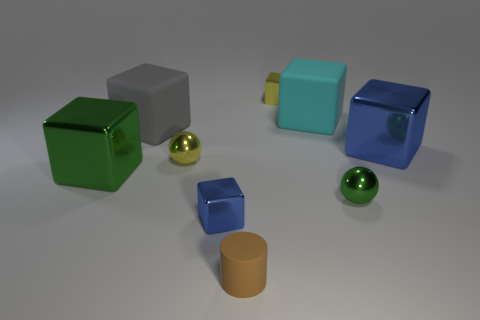Do the metal block that is behind the large gray matte cube and the block on the right side of the cyan rubber block have the same size?
Give a very brief answer. No. There is a cyan matte object; how many metallic cubes are on the left side of it?
Provide a short and direct response. 3. Is there a tiny blue thing that has the same material as the small cylinder?
Give a very brief answer. No. There is a blue thing that is the same size as the cylinder; what material is it?
Make the answer very short. Metal. There is a metal block that is both to the left of the small brown object and on the right side of the tiny yellow metallic sphere; how big is it?
Ensure brevity in your answer.  Small. The object that is behind the large gray matte cube and in front of the tiny yellow metal cube is what color?
Provide a succinct answer. Cyan. Is the number of yellow metal things that are in front of the big gray cube less than the number of big blocks that are behind the tiny brown rubber thing?
Your answer should be compact. Yes. How many large objects have the same shape as the tiny brown matte thing?
Give a very brief answer. 0. There is a green cube that is the same material as the small yellow cube; what size is it?
Ensure brevity in your answer.  Large. What is the color of the large metallic object to the left of the blue thing to the left of the small brown matte cylinder?
Offer a very short reply. Green. 